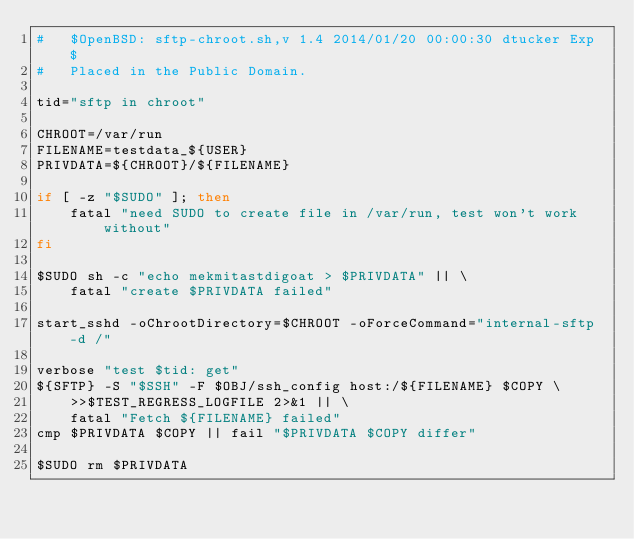Convert code to text. <code><loc_0><loc_0><loc_500><loc_500><_Bash_>#	$OpenBSD: sftp-chroot.sh,v 1.4 2014/01/20 00:00:30 dtucker Exp $
#	Placed in the Public Domain.

tid="sftp in chroot"

CHROOT=/var/run
FILENAME=testdata_${USER}
PRIVDATA=${CHROOT}/${FILENAME}

if [ -z "$SUDO" ]; then
	fatal "need SUDO to create file in /var/run, test won't work without"
fi

$SUDO sh -c "echo mekmitastdigoat > $PRIVDATA" || \
	fatal "create $PRIVDATA failed"

start_sshd -oChrootDirectory=$CHROOT -oForceCommand="internal-sftp -d /"

verbose "test $tid: get"
${SFTP} -S "$SSH" -F $OBJ/ssh_config host:/${FILENAME} $COPY \
    >>$TEST_REGRESS_LOGFILE 2>&1 || \
	fatal "Fetch ${FILENAME} failed"
cmp $PRIVDATA $COPY || fail "$PRIVDATA $COPY differ"

$SUDO rm $PRIVDATA
</code> 